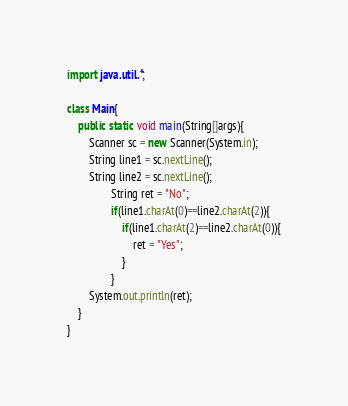Convert code to text. <code><loc_0><loc_0><loc_500><loc_500><_Java_>import java.util.*;
 
class Main{
    public static void main(String[]args){
		Scanner sc = new Scanner(System.in);
		String line1 = sc.nextLine();
		String line2 = sc.nextLine();
                String ret = "No";
                if(line1.charAt(0)==line2.charAt(2)){
                    if(line1.charAt(2)==line2.charAt(0)){
                        ret = "Yes";
                    }
                }
		System.out.println(ret);
    }
}</code> 